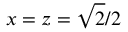Convert formula to latex. <formula><loc_0><loc_0><loc_500><loc_500>x = z = \sqrt { 2 } / 2</formula> 